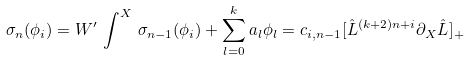Convert formula to latex. <formula><loc_0><loc_0><loc_500><loc_500>\sigma _ { n } ( \phi _ { i } ) = W ^ { \prime } \, \int ^ { X } \, \sigma _ { n - 1 } ( \phi _ { i } ) + \sum _ { l = 0 } ^ { k } a _ { l } \phi _ { l } = c _ { i , n - 1 } [ { \hat { L } } ^ { ( k + 2 ) n + i } \partial _ { X } { \hat { L } } ] _ { + }</formula> 